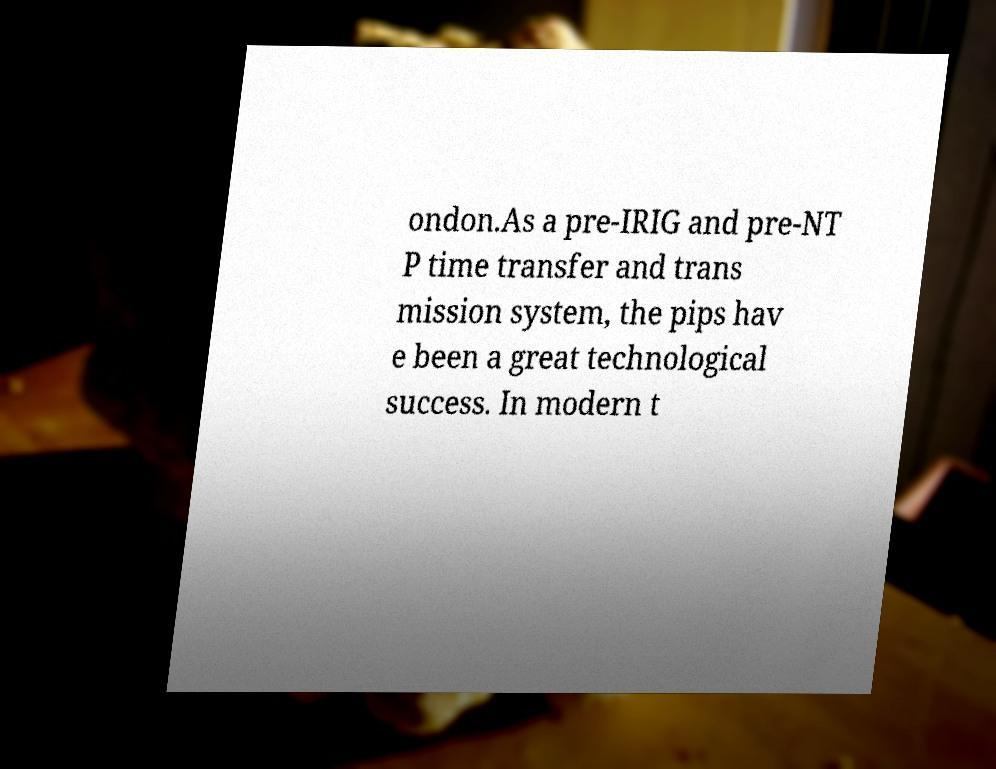For documentation purposes, I need the text within this image transcribed. Could you provide that? ondon.As a pre-IRIG and pre-NT P time transfer and trans mission system, the pips hav e been a great technological success. In modern t 